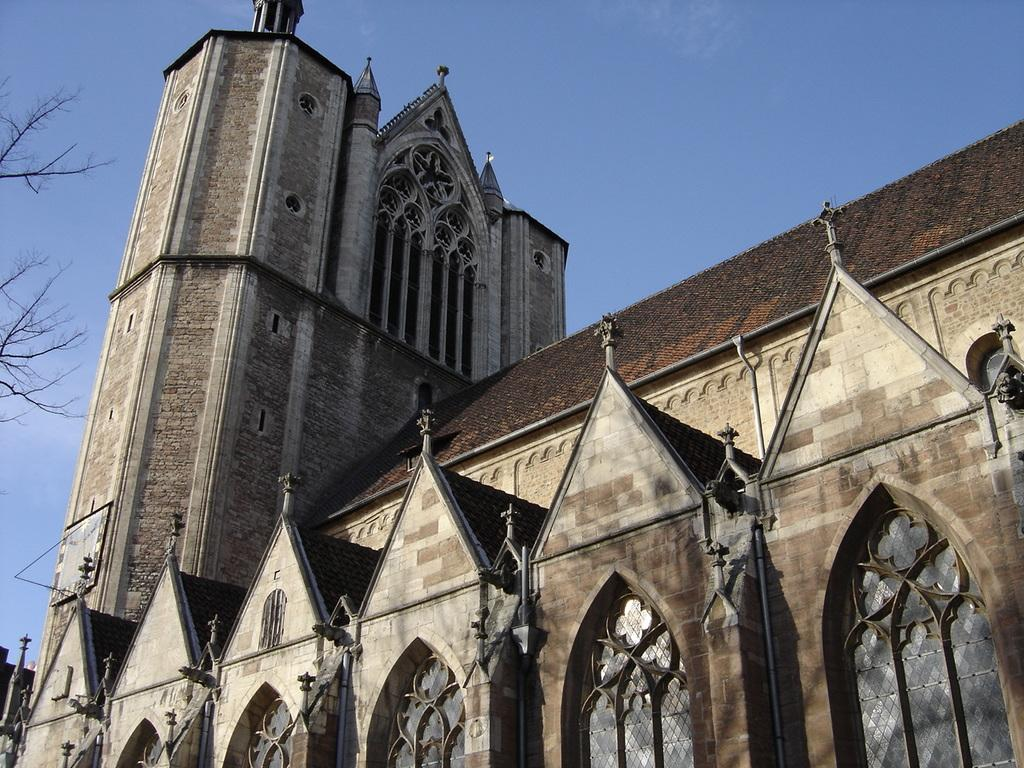What is the main structure visible in the image? There is a building in the front of the image. What can be seen on the left side of the image? There are branches of a tree on the left side of the image. What is visible in the background of the image? The sky is visible in the background of the image. What type of breakfast is being served in the room in the image? There is no room or breakfast present in the image; it only features a building, tree branches, and the sky. 